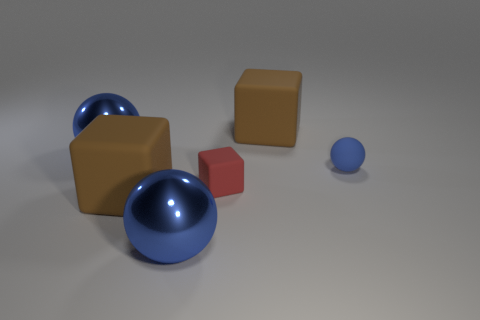Subtract all blue balls. How many were subtracted if there are1blue balls left? 2 Add 1 shiny cubes. How many objects exist? 7 Add 2 large yellow rubber balls. How many large yellow rubber balls exist? 2 Subtract 0 yellow balls. How many objects are left? 6 Subtract all large brown cubes. Subtract all small red things. How many objects are left? 3 Add 4 rubber things. How many rubber things are left? 8 